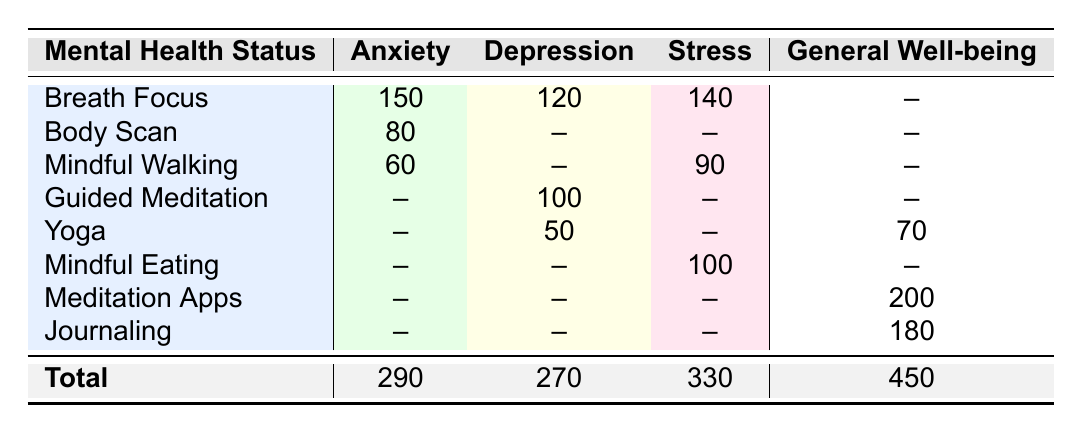What is the most common mindfulness technique used by individuals with Anxiety? The most common technique for Anxiety can be found in the "Anxiety" column. The technique "Breath Focus" has the highest count of 150 compared to Body Scan (80) and Mindful Walking (60).
Answer: Breath Focus How many individuals with Depression use Guided Meditation? In the Depression row, the count for Guided Meditation is directly provided in the table, which is 100.
Answer: 100 Which mindfulness technique is associated with the highest count for General Well-being? Looking at the General Well-being column, Meditation Apps has the highest count of 200, compared to Journaling (180) and Yoga (70).
Answer: Meditation Apps What is the total count of individuals practicing Breath Focus across all mental health statuses? To find the total for Breath Focus, we need to gather counts from all relevant rows: Anxiety (150), Depression (120), Stress (140). Adding these gives us 150 + 120 + 140 = 410.
Answer: 410 Is there any mindfulness technique used by individuals with Depression that has more participants than the technique used for Anxiety? In the Depression column, the highest technique is Breath Focus (120) and Guided Meditation (100), both of which do not exceed the highest technique for Anxiety which is Breath Focus (150). Therefore, no technique in Depression has more participants than Anxiety's Breath Focus.
Answer: No How many more individuals practice mindful walking under Stress than Body Scan under Anxiety? For Mindful Walking in Stress, the count is 90, while for Body Scan in Anxiety, the count is 80. The difference is 90 - 80 = 10, indicating that 10 more individuals practice Mindful Walking under Stress.
Answer: 10 What is the total count of individuals practicing yoga across all mental health statuses? From the table, we find that individuals practicing Yoga are 50 for Depression and 70 for General Well-being. By summing these counts: 50 + 70 = 120.
Answer: 120 Which mental health status has the least number of participants overall? To find the mental health status with the fewest participants, we compare the totals: Anxiety (290), Depression (270), Stress (330), and General Well-being (450). The lowest total is for Depression at 270.
Answer: Depression Are there any mindfulness techniques with zero counts listed in the table? Checking through each mental health status and technique, we see no listed counts equal to zero; all techniques have at least some participants using them.
Answer: No 